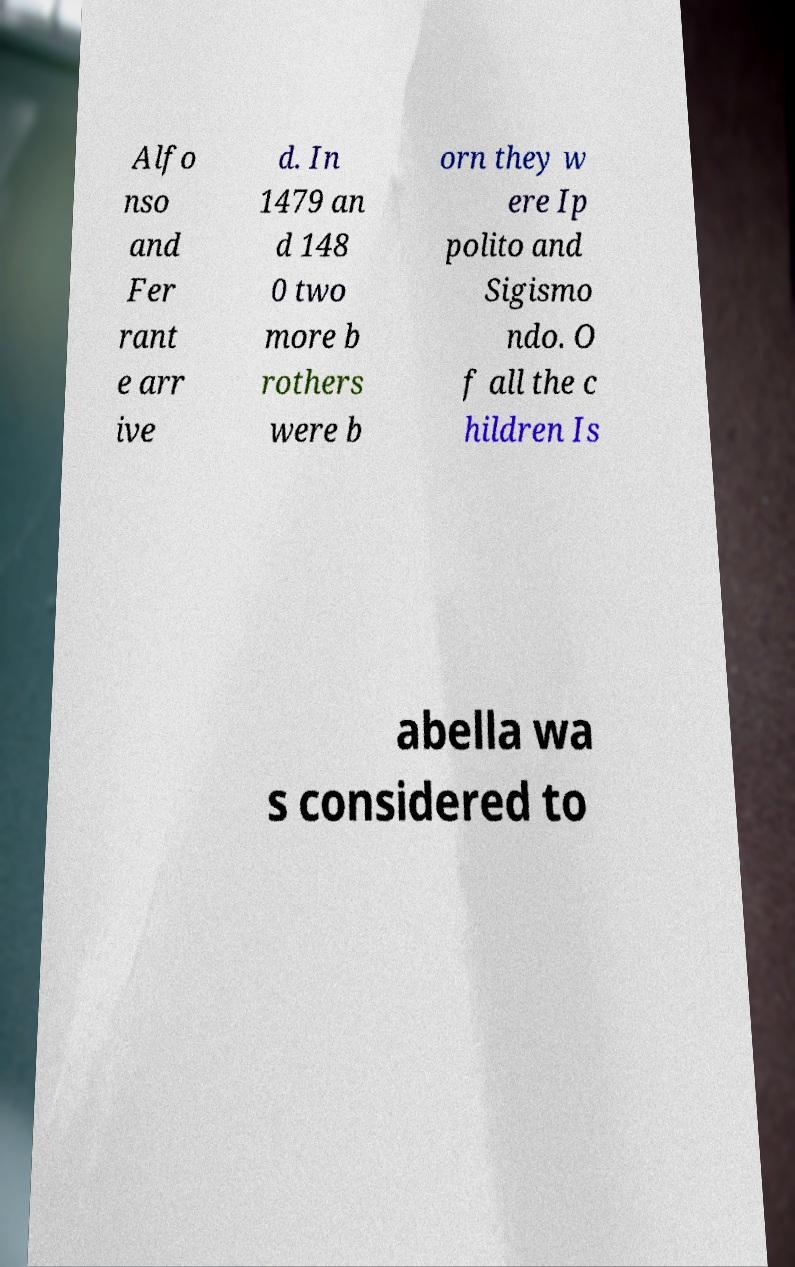Could you assist in decoding the text presented in this image and type it out clearly? Alfo nso and Fer rant e arr ive d. In 1479 an d 148 0 two more b rothers were b orn they w ere Ip polito and Sigismo ndo. O f all the c hildren Is abella wa s considered to 